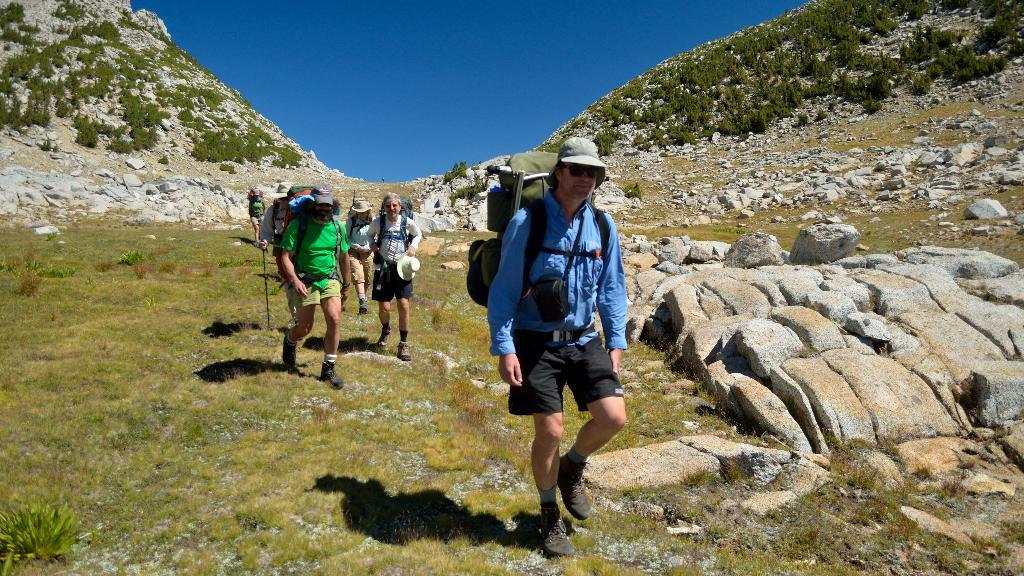What are the people in the image doing? The people in the image are walking on the grass. What are the people holding while walking? The people are holding bags. What can be seen in the distance in the image? There are mountains in the background of the image. What type of ground surface is visible in the image? There are stones visible in the image. What type of vegetation is present in the image? There are plants in the image. What is visible above the people and the landscape? The sky is visible in the image. What type of jar can be seen on the bed in the image? There is no jar or bed present in the image; it features people walking on the grass with bags, mountains in the background, stones, plants, and a visible sky. 